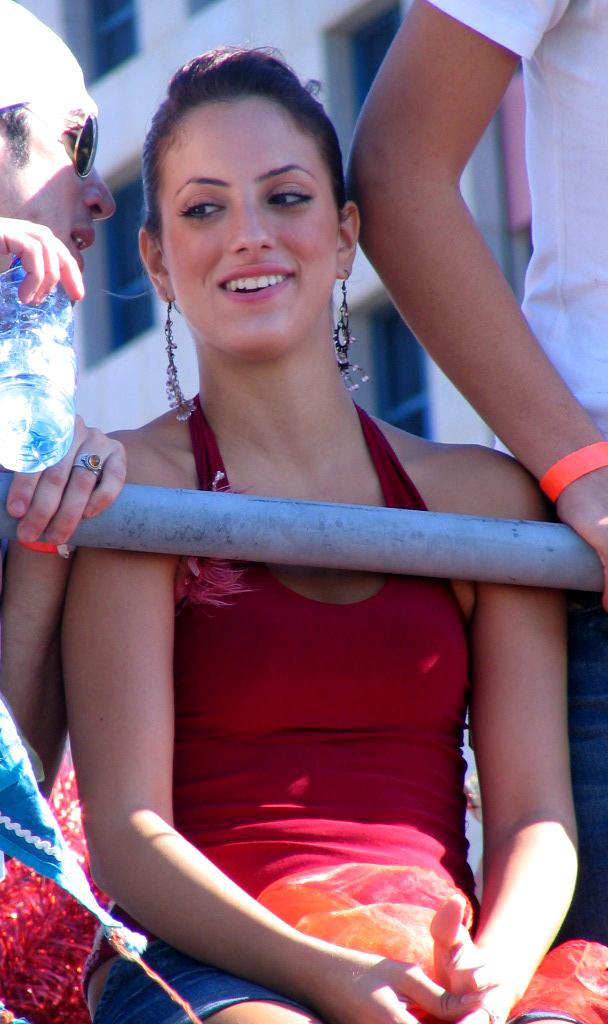What is the woman in the image doing? The woman is sitting and smiling in the image. How many people are present in the image? There are three persons in the image, including the woman. What object can be seen in the image besides the people? There is a bottle and a rod in the image. What can be seen in the background of the image? There is a building with windows in the background of the image. What type of waste is being disposed of in the image? There is no waste disposal visible in the image. The image features a woman sitting and smiling, two other persons, a bottle, a rod, and a building with windows in the background. 